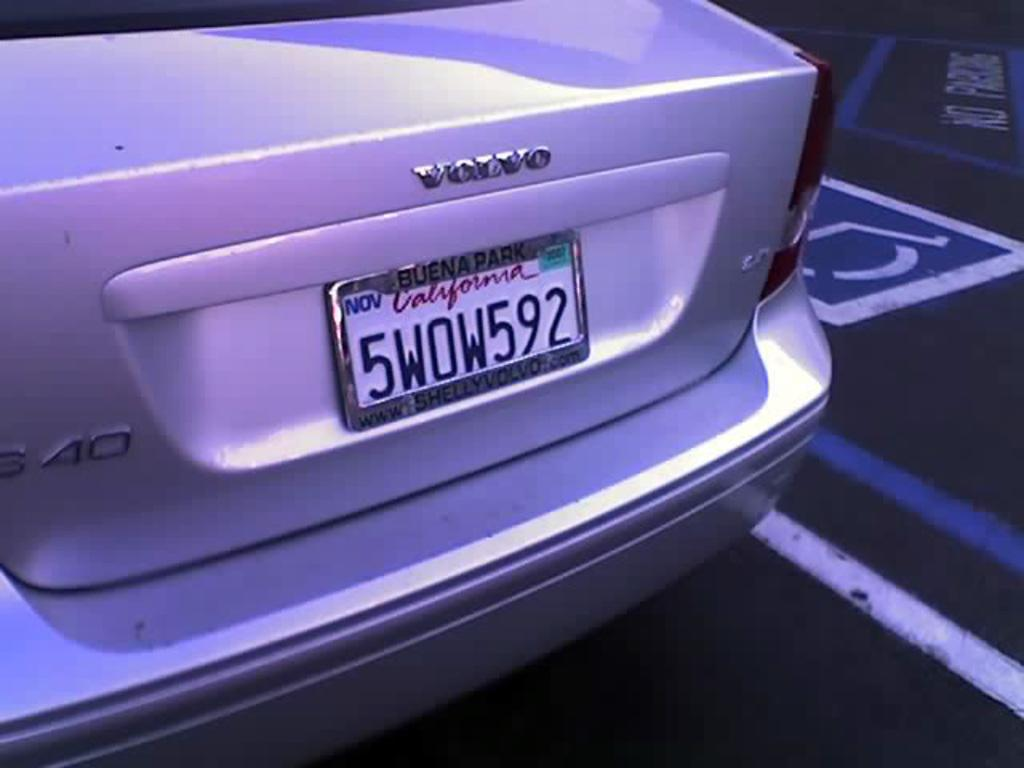<image>
Share a concise interpretation of the image provided. A silver Volvo with a California tag that reads 5WOW592. 